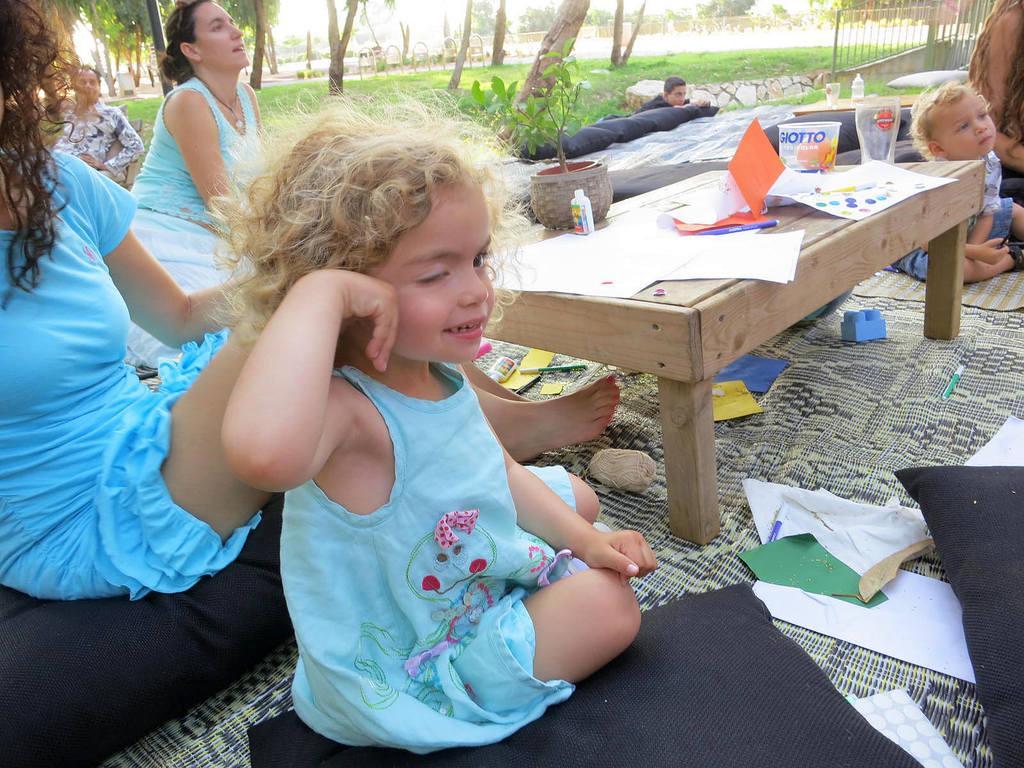Please provide a concise description of this image. In this image there is a table in the middle and there are people around it. There is a small girl who is sitting on the mat and a woman is sitting on the bed which is beside the small girl. On the table there is flower pot,glass,paper,pen. On the mat there are lego toys,pillow,glue. In the background there are trees and grass. On the top right corner there is a railing. 